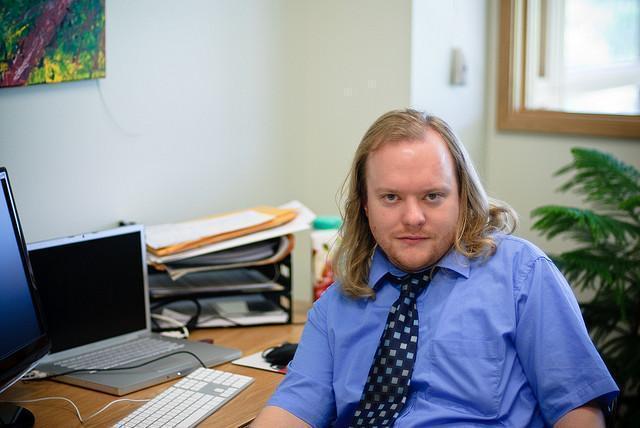What location does this man work in?
From the following set of four choices, select the accurate answer to respond to the question.
Options: Clothing store, mall, office, stage. Office. 